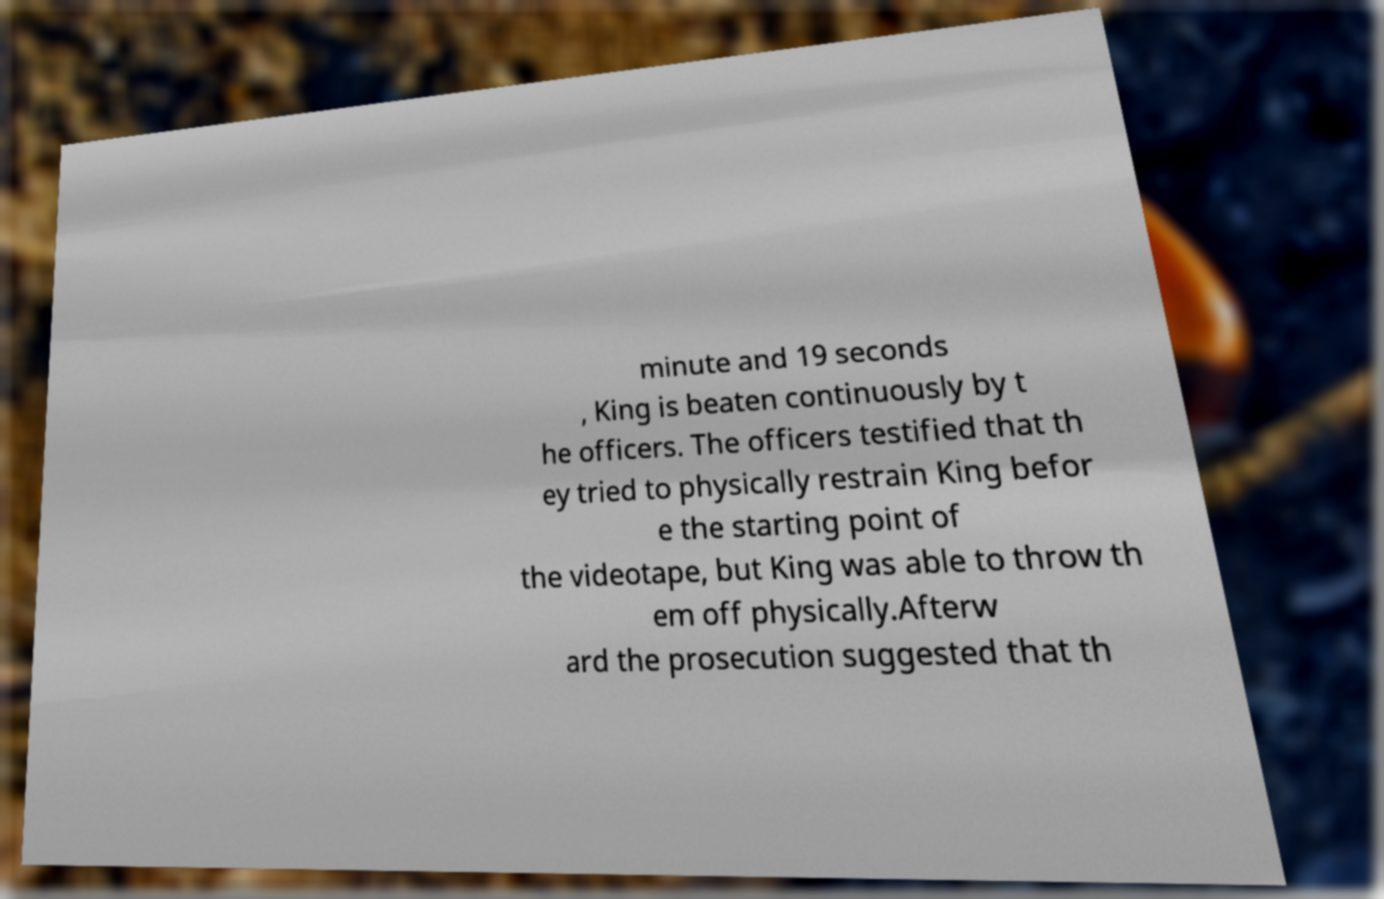Please read and relay the text visible in this image. What does it say? minute and 19 seconds , King is beaten continuously by t he officers. The officers testified that th ey tried to physically restrain King befor e the starting point of the videotape, but King was able to throw th em off physically.Afterw ard the prosecution suggested that th 